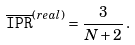<formula> <loc_0><loc_0><loc_500><loc_500>\overline { \tt I P R } ^ { ( r e a l ) } = \frac { 3 } { N + 2 } \, .</formula> 